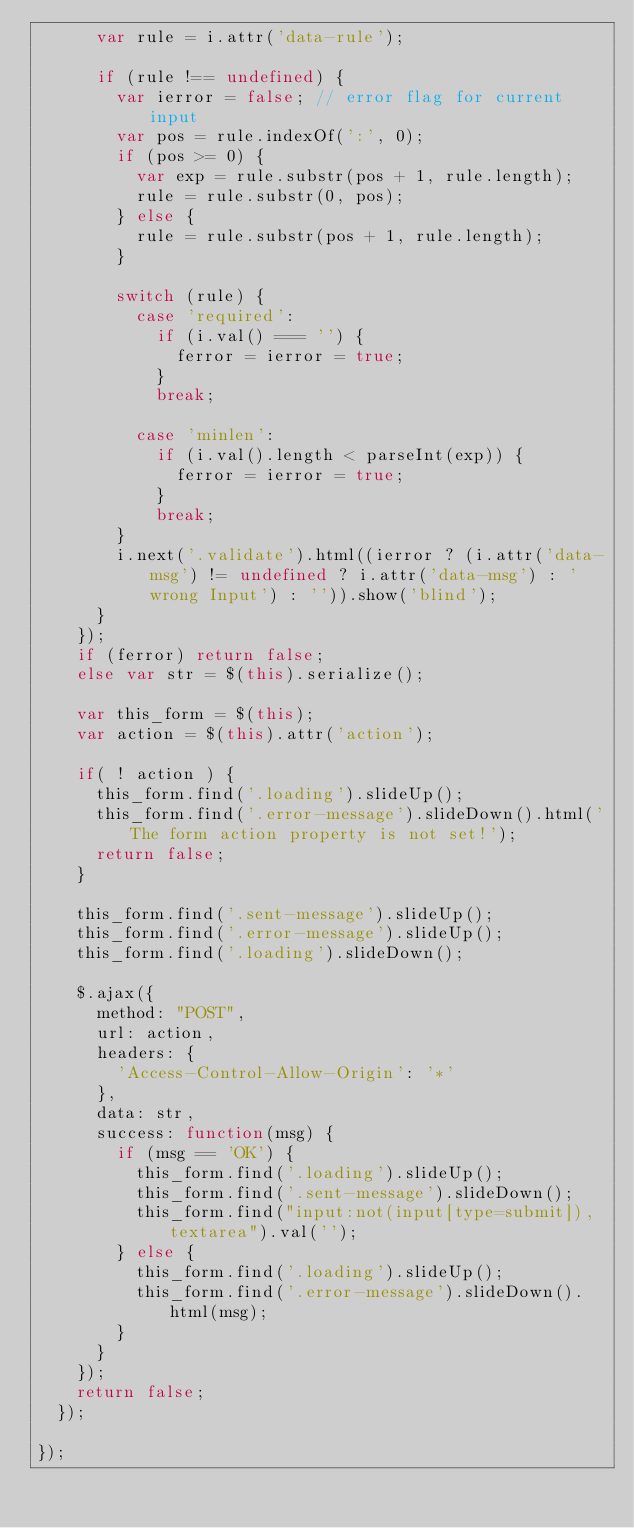Convert code to text. <code><loc_0><loc_0><loc_500><loc_500><_JavaScript_>      var rule = i.attr('data-rule');

      if (rule !== undefined) {
        var ierror = false; // error flag for current input
        var pos = rule.indexOf(':', 0);
        if (pos >= 0) {
          var exp = rule.substr(pos + 1, rule.length);
          rule = rule.substr(0, pos);
        } else {
          rule = rule.substr(pos + 1, rule.length);
        }

        switch (rule) {
          case 'required':
            if (i.val() === '') {
              ferror = ierror = true;
            }
            break;

          case 'minlen':
            if (i.val().length < parseInt(exp)) {
              ferror = ierror = true;
            }
            break;
        }
        i.next('.validate').html((ierror ? (i.attr('data-msg') != undefined ? i.attr('data-msg') : 'wrong Input') : '')).show('blind');
      }
    });
    if (ferror) return false;
    else var str = $(this).serialize();

    var this_form = $(this);
    var action = $(this).attr('action');

    if( ! action ) {
      this_form.find('.loading').slideUp();
      this_form.find('.error-message').slideDown().html('The form action property is not set!');
      return false;
    }
    
    this_form.find('.sent-message').slideUp();
    this_form.find('.error-message').slideUp();
    this_form.find('.loading').slideDown();
    
    $.ajax({
      method: "POST",
      url: action,
      headers: {
        'Access-Control-Allow-Origin': '*'
      },
      data: str,
      success: function(msg) {
        if (msg == 'OK') {
          this_form.find('.loading').slideUp();
          this_form.find('.sent-message').slideDown();
          this_form.find("input:not(input[type=submit]), textarea").val('');
        } else {
          this_form.find('.loading').slideUp();
          this_form.find('.error-message').slideDown().html(msg);
        }
      }
    });
    return false;
  });

});
</code> 